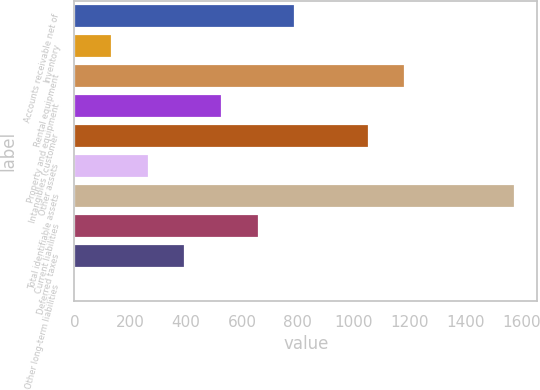Convert chart to OTSL. <chart><loc_0><loc_0><loc_500><loc_500><bar_chart><fcel>Accounts receivable net of<fcel>Inventory<fcel>Rental equipment<fcel>Property and equipment<fcel>Intangibles (customer<fcel>Other assets<fcel>Total identifiable assets<fcel>Current liabilities<fcel>Deferred taxes<fcel>Other long-term liabilities<nl><fcel>790.8<fcel>134.3<fcel>1184.7<fcel>528.2<fcel>1053.4<fcel>265.6<fcel>1578.6<fcel>659.5<fcel>396.9<fcel>3<nl></chart> 